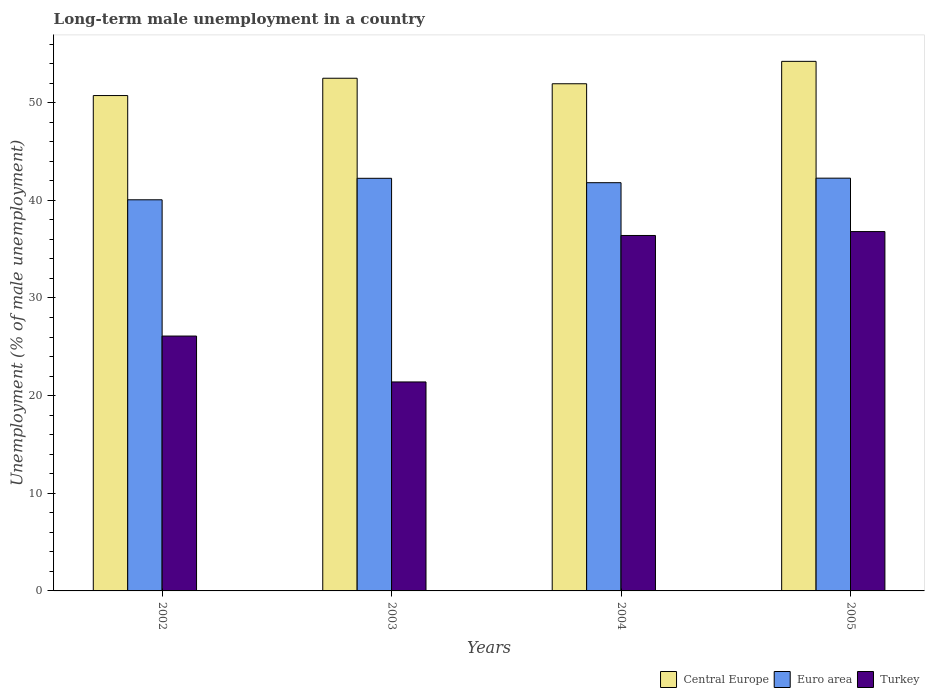How many groups of bars are there?
Ensure brevity in your answer.  4. How many bars are there on the 1st tick from the left?
Make the answer very short. 3. How many bars are there on the 1st tick from the right?
Your answer should be very brief. 3. What is the label of the 1st group of bars from the left?
Give a very brief answer. 2002. What is the percentage of long-term unemployed male population in Turkey in 2002?
Provide a succinct answer. 26.1. Across all years, what is the maximum percentage of long-term unemployed male population in Euro area?
Give a very brief answer. 42.27. Across all years, what is the minimum percentage of long-term unemployed male population in Euro area?
Your answer should be compact. 40.05. What is the total percentage of long-term unemployed male population in Euro area in the graph?
Offer a terse response. 166.38. What is the difference between the percentage of long-term unemployed male population in Turkey in 2002 and that in 2004?
Your answer should be compact. -10.3. What is the difference between the percentage of long-term unemployed male population in Euro area in 2002 and the percentage of long-term unemployed male population in Central Europe in 2004?
Your answer should be very brief. -11.88. What is the average percentage of long-term unemployed male population in Euro area per year?
Ensure brevity in your answer.  41.6. In the year 2004, what is the difference between the percentage of long-term unemployed male population in Turkey and percentage of long-term unemployed male population in Euro area?
Offer a very short reply. -5.4. What is the ratio of the percentage of long-term unemployed male population in Central Europe in 2004 to that in 2005?
Keep it short and to the point. 0.96. Is the percentage of long-term unemployed male population in Euro area in 2003 less than that in 2004?
Give a very brief answer. No. Is the difference between the percentage of long-term unemployed male population in Turkey in 2004 and 2005 greater than the difference between the percentage of long-term unemployed male population in Euro area in 2004 and 2005?
Ensure brevity in your answer.  Yes. What is the difference between the highest and the second highest percentage of long-term unemployed male population in Euro area?
Keep it short and to the point. 0.01. What is the difference between the highest and the lowest percentage of long-term unemployed male population in Turkey?
Offer a very short reply. 15.4. In how many years, is the percentage of long-term unemployed male population in Euro area greater than the average percentage of long-term unemployed male population in Euro area taken over all years?
Your response must be concise. 3. Is the sum of the percentage of long-term unemployed male population in Euro area in 2004 and 2005 greater than the maximum percentage of long-term unemployed male population in Central Europe across all years?
Provide a short and direct response. Yes. What does the 3rd bar from the left in 2005 represents?
Offer a very short reply. Turkey. Is it the case that in every year, the sum of the percentage of long-term unemployed male population in Euro area and percentage of long-term unemployed male population in Central Europe is greater than the percentage of long-term unemployed male population in Turkey?
Provide a succinct answer. Yes. Are all the bars in the graph horizontal?
Your answer should be compact. No. How many years are there in the graph?
Offer a terse response. 4. What is the difference between two consecutive major ticks on the Y-axis?
Offer a very short reply. 10. Are the values on the major ticks of Y-axis written in scientific E-notation?
Make the answer very short. No. Does the graph contain any zero values?
Keep it short and to the point. No. Does the graph contain grids?
Offer a very short reply. No. Where does the legend appear in the graph?
Give a very brief answer. Bottom right. How many legend labels are there?
Give a very brief answer. 3. What is the title of the graph?
Offer a very short reply. Long-term male unemployment in a country. Does "Zambia" appear as one of the legend labels in the graph?
Offer a terse response. No. What is the label or title of the Y-axis?
Your response must be concise. Unemployment (% of male unemployment). What is the Unemployment (% of male unemployment) in Central Europe in 2002?
Offer a very short reply. 50.73. What is the Unemployment (% of male unemployment) in Euro area in 2002?
Provide a short and direct response. 40.05. What is the Unemployment (% of male unemployment) in Turkey in 2002?
Keep it short and to the point. 26.1. What is the Unemployment (% of male unemployment) of Central Europe in 2003?
Your answer should be very brief. 52.5. What is the Unemployment (% of male unemployment) of Euro area in 2003?
Your answer should be very brief. 42.25. What is the Unemployment (% of male unemployment) of Turkey in 2003?
Your response must be concise. 21.4. What is the Unemployment (% of male unemployment) of Central Europe in 2004?
Your answer should be very brief. 51.94. What is the Unemployment (% of male unemployment) of Euro area in 2004?
Your answer should be very brief. 41.8. What is the Unemployment (% of male unemployment) of Turkey in 2004?
Keep it short and to the point. 36.4. What is the Unemployment (% of male unemployment) in Central Europe in 2005?
Make the answer very short. 54.23. What is the Unemployment (% of male unemployment) in Euro area in 2005?
Your answer should be very brief. 42.27. What is the Unemployment (% of male unemployment) of Turkey in 2005?
Your answer should be compact. 36.8. Across all years, what is the maximum Unemployment (% of male unemployment) of Central Europe?
Give a very brief answer. 54.23. Across all years, what is the maximum Unemployment (% of male unemployment) of Euro area?
Keep it short and to the point. 42.27. Across all years, what is the maximum Unemployment (% of male unemployment) of Turkey?
Make the answer very short. 36.8. Across all years, what is the minimum Unemployment (% of male unemployment) in Central Europe?
Offer a very short reply. 50.73. Across all years, what is the minimum Unemployment (% of male unemployment) in Euro area?
Your response must be concise. 40.05. Across all years, what is the minimum Unemployment (% of male unemployment) of Turkey?
Provide a short and direct response. 21.4. What is the total Unemployment (% of male unemployment) of Central Europe in the graph?
Give a very brief answer. 209.4. What is the total Unemployment (% of male unemployment) in Euro area in the graph?
Ensure brevity in your answer.  166.38. What is the total Unemployment (% of male unemployment) of Turkey in the graph?
Your answer should be compact. 120.7. What is the difference between the Unemployment (% of male unemployment) in Central Europe in 2002 and that in 2003?
Your response must be concise. -1.77. What is the difference between the Unemployment (% of male unemployment) in Euro area in 2002 and that in 2003?
Make the answer very short. -2.2. What is the difference between the Unemployment (% of male unemployment) of Central Europe in 2002 and that in 2004?
Your response must be concise. -1.21. What is the difference between the Unemployment (% of male unemployment) in Euro area in 2002 and that in 2004?
Your answer should be very brief. -1.75. What is the difference between the Unemployment (% of male unemployment) in Central Europe in 2002 and that in 2005?
Keep it short and to the point. -3.5. What is the difference between the Unemployment (% of male unemployment) in Euro area in 2002 and that in 2005?
Your answer should be compact. -2.21. What is the difference between the Unemployment (% of male unemployment) in Central Europe in 2003 and that in 2004?
Offer a very short reply. 0.57. What is the difference between the Unemployment (% of male unemployment) of Euro area in 2003 and that in 2004?
Offer a very short reply. 0.45. What is the difference between the Unemployment (% of male unemployment) of Central Europe in 2003 and that in 2005?
Your response must be concise. -1.73. What is the difference between the Unemployment (% of male unemployment) in Euro area in 2003 and that in 2005?
Provide a succinct answer. -0.01. What is the difference between the Unemployment (% of male unemployment) of Turkey in 2003 and that in 2005?
Ensure brevity in your answer.  -15.4. What is the difference between the Unemployment (% of male unemployment) in Central Europe in 2004 and that in 2005?
Give a very brief answer. -2.3. What is the difference between the Unemployment (% of male unemployment) in Euro area in 2004 and that in 2005?
Your answer should be compact. -0.46. What is the difference between the Unemployment (% of male unemployment) in Turkey in 2004 and that in 2005?
Keep it short and to the point. -0.4. What is the difference between the Unemployment (% of male unemployment) of Central Europe in 2002 and the Unemployment (% of male unemployment) of Euro area in 2003?
Provide a succinct answer. 8.47. What is the difference between the Unemployment (% of male unemployment) in Central Europe in 2002 and the Unemployment (% of male unemployment) in Turkey in 2003?
Provide a succinct answer. 29.33. What is the difference between the Unemployment (% of male unemployment) of Euro area in 2002 and the Unemployment (% of male unemployment) of Turkey in 2003?
Make the answer very short. 18.65. What is the difference between the Unemployment (% of male unemployment) of Central Europe in 2002 and the Unemployment (% of male unemployment) of Euro area in 2004?
Your response must be concise. 8.92. What is the difference between the Unemployment (% of male unemployment) in Central Europe in 2002 and the Unemployment (% of male unemployment) in Turkey in 2004?
Offer a terse response. 14.33. What is the difference between the Unemployment (% of male unemployment) of Euro area in 2002 and the Unemployment (% of male unemployment) of Turkey in 2004?
Make the answer very short. 3.65. What is the difference between the Unemployment (% of male unemployment) in Central Europe in 2002 and the Unemployment (% of male unemployment) in Euro area in 2005?
Give a very brief answer. 8.46. What is the difference between the Unemployment (% of male unemployment) of Central Europe in 2002 and the Unemployment (% of male unemployment) of Turkey in 2005?
Make the answer very short. 13.93. What is the difference between the Unemployment (% of male unemployment) of Euro area in 2002 and the Unemployment (% of male unemployment) of Turkey in 2005?
Your answer should be very brief. 3.25. What is the difference between the Unemployment (% of male unemployment) in Central Europe in 2003 and the Unemployment (% of male unemployment) in Euro area in 2004?
Offer a terse response. 10.7. What is the difference between the Unemployment (% of male unemployment) in Central Europe in 2003 and the Unemployment (% of male unemployment) in Turkey in 2004?
Ensure brevity in your answer.  16.1. What is the difference between the Unemployment (% of male unemployment) in Euro area in 2003 and the Unemployment (% of male unemployment) in Turkey in 2004?
Offer a terse response. 5.85. What is the difference between the Unemployment (% of male unemployment) of Central Europe in 2003 and the Unemployment (% of male unemployment) of Euro area in 2005?
Your answer should be compact. 10.23. What is the difference between the Unemployment (% of male unemployment) in Central Europe in 2003 and the Unemployment (% of male unemployment) in Turkey in 2005?
Provide a short and direct response. 15.7. What is the difference between the Unemployment (% of male unemployment) of Euro area in 2003 and the Unemployment (% of male unemployment) of Turkey in 2005?
Ensure brevity in your answer.  5.45. What is the difference between the Unemployment (% of male unemployment) in Central Europe in 2004 and the Unemployment (% of male unemployment) in Euro area in 2005?
Offer a terse response. 9.67. What is the difference between the Unemployment (% of male unemployment) of Central Europe in 2004 and the Unemployment (% of male unemployment) of Turkey in 2005?
Give a very brief answer. 15.14. What is the difference between the Unemployment (% of male unemployment) in Euro area in 2004 and the Unemployment (% of male unemployment) in Turkey in 2005?
Provide a short and direct response. 5. What is the average Unemployment (% of male unemployment) of Central Europe per year?
Provide a short and direct response. 52.35. What is the average Unemployment (% of male unemployment) of Euro area per year?
Your response must be concise. 41.6. What is the average Unemployment (% of male unemployment) of Turkey per year?
Provide a succinct answer. 30.18. In the year 2002, what is the difference between the Unemployment (% of male unemployment) in Central Europe and Unemployment (% of male unemployment) in Euro area?
Ensure brevity in your answer.  10.67. In the year 2002, what is the difference between the Unemployment (% of male unemployment) in Central Europe and Unemployment (% of male unemployment) in Turkey?
Give a very brief answer. 24.63. In the year 2002, what is the difference between the Unemployment (% of male unemployment) in Euro area and Unemployment (% of male unemployment) in Turkey?
Offer a very short reply. 13.95. In the year 2003, what is the difference between the Unemployment (% of male unemployment) of Central Europe and Unemployment (% of male unemployment) of Euro area?
Provide a short and direct response. 10.25. In the year 2003, what is the difference between the Unemployment (% of male unemployment) of Central Europe and Unemployment (% of male unemployment) of Turkey?
Your answer should be compact. 31.1. In the year 2003, what is the difference between the Unemployment (% of male unemployment) of Euro area and Unemployment (% of male unemployment) of Turkey?
Offer a very short reply. 20.85. In the year 2004, what is the difference between the Unemployment (% of male unemployment) of Central Europe and Unemployment (% of male unemployment) of Euro area?
Provide a short and direct response. 10.13. In the year 2004, what is the difference between the Unemployment (% of male unemployment) of Central Europe and Unemployment (% of male unemployment) of Turkey?
Provide a succinct answer. 15.54. In the year 2004, what is the difference between the Unemployment (% of male unemployment) of Euro area and Unemployment (% of male unemployment) of Turkey?
Provide a short and direct response. 5.4. In the year 2005, what is the difference between the Unemployment (% of male unemployment) in Central Europe and Unemployment (% of male unemployment) in Euro area?
Offer a very short reply. 11.96. In the year 2005, what is the difference between the Unemployment (% of male unemployment) of Central Europe and Unemployment (% of male unemployment) of Turkey?
Provide a short and direct response. 17.43. In the year 2005, what is the difference between the Unemployment (% of male unemployment) in Euro area and Unemployment (% of male unemployment) in Turkey?
Your answer should be compact. 5.47. What is the ratio of the Unemployment (% of male unemployment) of Central Europe in 2002 to that in 2003?
Keep it short and to the point. 0.97. What is the ratio of the Unemployment (% of male unemployment) in Euro area in 2002 to that in 2003?
Ensure brevity in your answer.  0.95. What is the ratio of the Unemployment (% of male unemployment) in Turkey in 2002 to that in 2003?
Provide a short and direct response. 1.22. What is the ratio of the Unemployment (% of male unemployment) of Central Europe in 2002 to that in 2004?
Provide a short and direct response. 0.98. What is the ratio of the Unemployment (% of male unemployment) in Euro area in 2002 to that in 2004?
Provide a succinct answer. 0.96. What is the ratio of the Unemployment (% of male unemployment) in Turkey in 2002 to that in 2004?
Make the answer very short. 0.72. What is the ratio of the Unemployment (% of male unemployment) of Central Europe in 2002 to that in 2005?
Keep it short and to the point. 0.94. What is the ratio of the Unemployment (% of male unemployment) in Euro area in 2002 to that in 2005?
Offer a very short reply. 0.95. What is the ratio of the Unemployment (% of male unemployment) in Turkey in 2002 to that in 2005?
Your answer should be compact. 0.71. What is the ratio of the Unemployment (% of male unemployment) in Central Europe in 2003 to that in 2004?
Provide a succinct answer. 1.01. What is the ratio of the Unemployment (% of male unemployment) in Euro area in 2003 to that in 2004?
Ensure brevity in your answer.  1.01. What is the ratio of the Unemployment (% of male unemployment) in Turkey in 2003 to that in 2004?
Offer a terse response. 0.59. What is the ratio of the Unemployment (% of male unemployment) in Central Europe in 2003 to that in 2005?
Offer a terse response. 0.97. What is the ratio of the Unemployment (% of male unemployment) of Euro area in 2003 to that in 2005?
Your answer should be compact. 1. What is the ratio of the Unemployment (% of male unemployment) in Turkey in 2003 to that in 2005?
Give a very brief answer. 0.58. What is the ratio of the Unemployment (% of male unemployment) of Central Europe in 2004 to that in 2005?
Make the answer very short. 0.96. What is the difference between the highest and the second highest Unemployment (% of male unemployment) of Central Europe?
Your response must be concise. 1.73. What is the difference between the highest and the second highest Unemployment (% of male unemployment) of Euro area?
Your response must be concise. 0.01. What is the difference between the highest and the lowest Unemployment (% of male unemployment) in Central Europe?
Offer a terse response. 3.5. What is the difference between the highest and the lowest Unemployment (% of male unemployment) in Euro area?
Your answer should be compact. 2.21. 